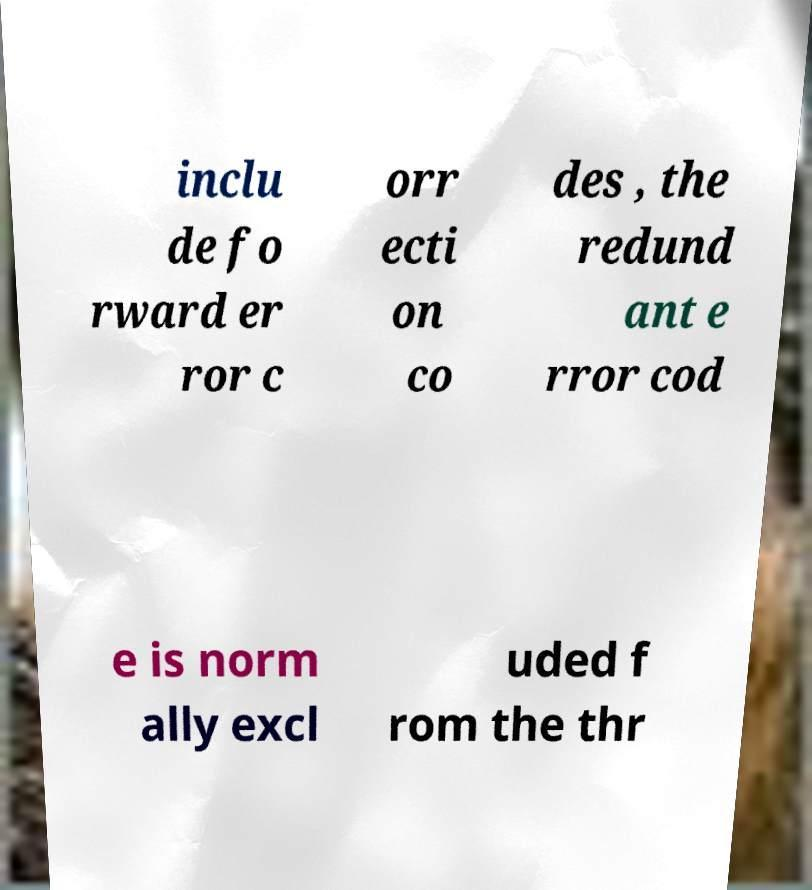Could you assist in decoding the text presented in this image and type it out clearly? inclu de fo rward er ror c orr ecti on co des , the redund ant e rror cod e is norm ally excl uded f rom the thr 